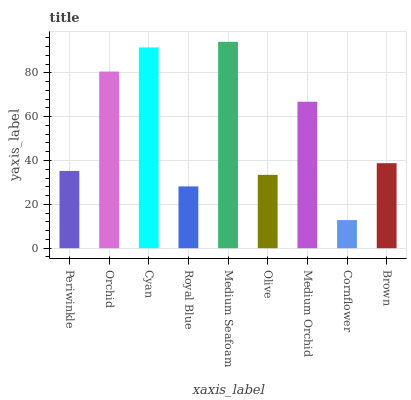Is Cornflower the minimum?
Answer yes or no. Yes. Is Medium Seafoam the maximum?
Answer yes or no. Yes. Is Orchid the minimum?
Answer yes or no. No. Is Orchid the maximum?
Answer yes or no. No. Is Orchid greater than Periwinkle?
Answer yes or no. Yes. Is Periwinkle less than Orchid?
Answer yes or no. Yes. Is Periwinkle greater than Orchid?
Answer yes or no. No. Is Orchid less than Periwinkle?
Answer yes or no. No. Is Brown the high median?
Answer yes or no. Yes. Is Brown the low median?
Answer yes or no. Yes. Is Olive the high median?
Answer yes or no. No. Is Olive the low median?
Answer yes or no. No. 